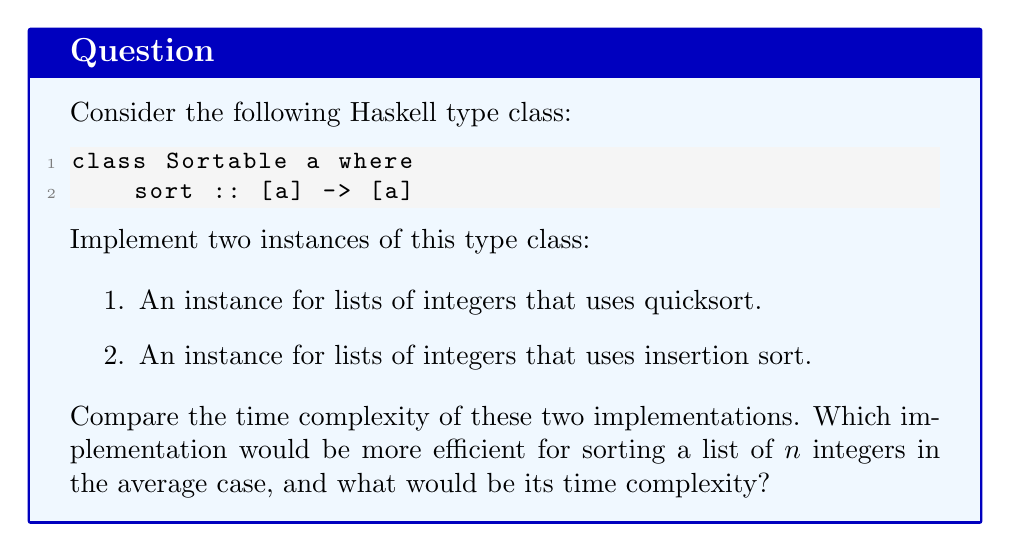Can you solve this math problem? Let's approach this step-by-step:

1. Quicksort implementation:
   ```haskell
   instance Sortable Int where
       sort [] = []
       sort (x:xs) = sort smaller ++ [x] ++ sort larger
           where
               smaller = [a | a <- xs, a <= x]
               larger  = [a | a <- xs, a > x]
   ```

2. Insertion sort implementation:
   ```haskell
   instance Sortable Int where
       sort [] = []
       sort (x:xs) = insert x (sort xs)
           where
               insert y [] = [y]
               insert y (z:zs)
                   | y <= z    = y : z : zs
                   | otherwise = z : insert y zs
   ```

3. Time complexity analysis:
   - Quicksort:
     * Average case: $O(n \log n)$
     * Worst case: $O(n^2)$ (when the pivot is always the smallest or largest element)
   
   - Insertion sort:
     * Average and worst case: $O(n^2)$

4. Comparison:
   In the average case, quicksort performs better than insertion sort.
   
   * Quicksort divides the list into two parts in each recursive step, leading to $\log n$ levels of recursion on average.
   * At each level, it performs $n$ comparisons, resulting in $O(n \log n)$ time complexity.
   * Insertion sort, on the other hand, needs to scan through the sorted portion of the list for each new element, leading to $O(n^2)$ comparisons.

5. Efficiency:
   For sorting a list of $n$ integers in the average case, the quicksort implementation would be more efficient.

Therefore, the quicksort implementation would be more efficient for sorting a list of $n$ integers in the average case, with a time complexity of $O(n \log n)$.
Answer: Quicksort, $O(n \log n)$ 